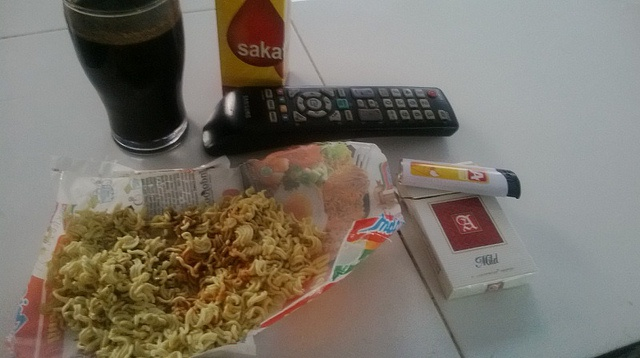Describe the objects in this image and their specific colors. I can see remote in darkgray, black, and gray tones and cup in darkgray, black, and gray tones in this image. 